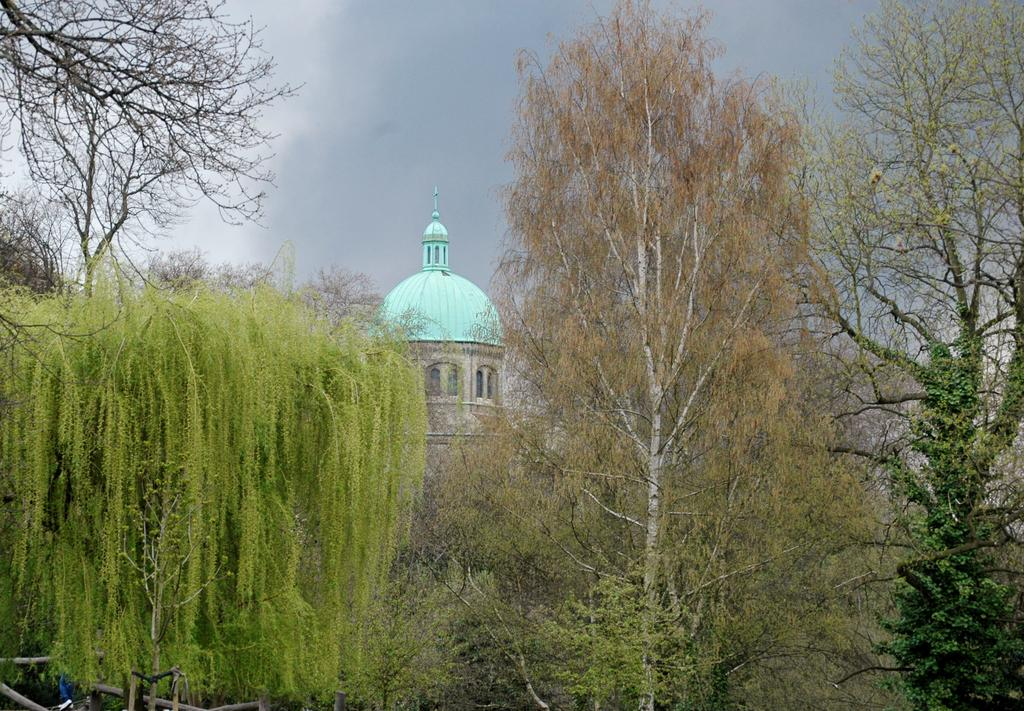What type of natural elements can be seen in the image? There are trees in the image. What type of materials are used for the objects in the image? There are wooden objects in the image. Can you describe any other objects in the image besides the trees and wooden objects? Yes, there are other objects in the image. What can be seen in the background of the image? There is a building and the sky visible in the background of the image. What type of pleasure can be seen on the floor in the image? There is no reference to pleasure or a floor in the image, so it is not possible to answer that question. 